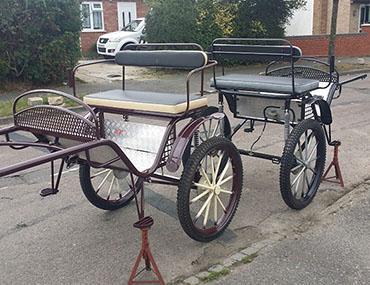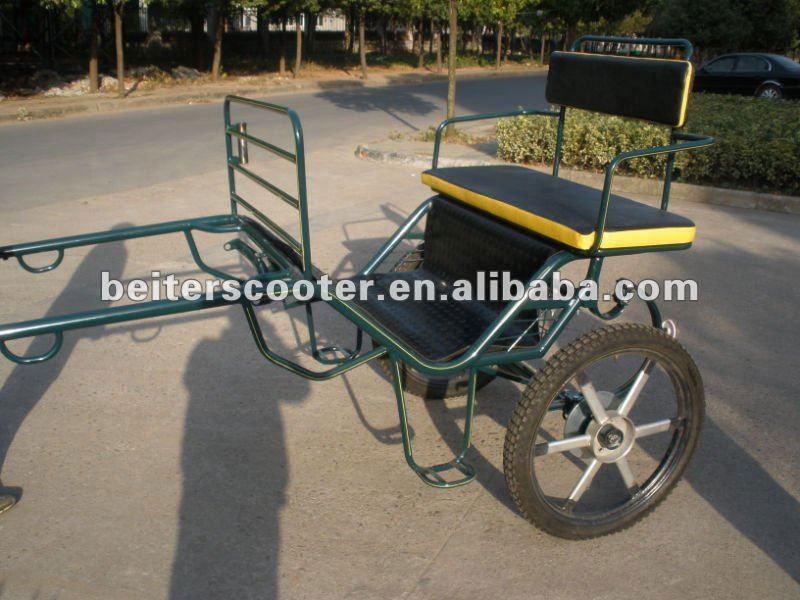The first image is the image on the left, the second image is the image on the right. Considering the images on both sides, is "One of the images has someone riding a horse carriage." valid? Answer yes or no. No. The first image is the image on the left, the second image is the image on the right. For the images displayed, is the sentence "There at least one person shown in one or both of the images." factually correct? Answer yes or no. No. 